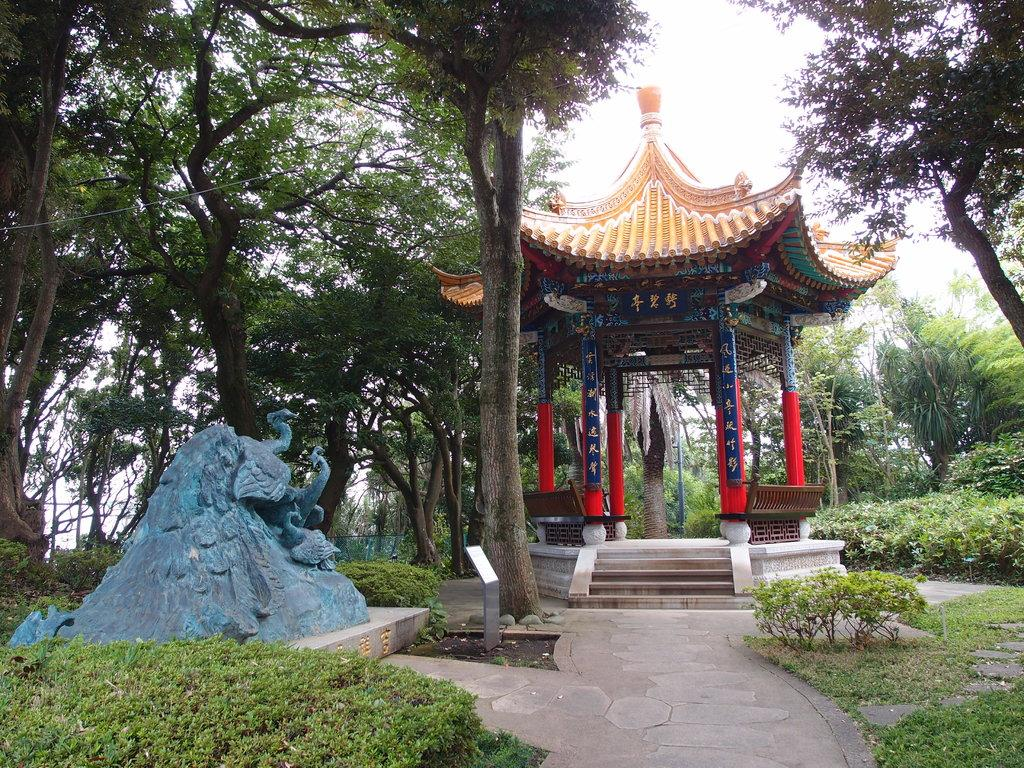What type of living organisms can be seen on the ground in the image? There are plants on the ground in the image. What type of structures are present in the image? There are statues in the image. What is located on the left side of the image? There is a metal object on the left side of the image. What type of structure can be seen in the background of the image? There is a gazebo in the background of the image. What type of vegetation is visible in the background of the image? There are trees in the background of the image. What else can be seen in the background of the image? There are objects in the background of the image. What is visible in the sky in the background of the image? The sky is visible in the background of the image. What type of songs can be heard playing from the vase in the image? There is no vase present in the image, and therefore no songs can be heard playing from it. 